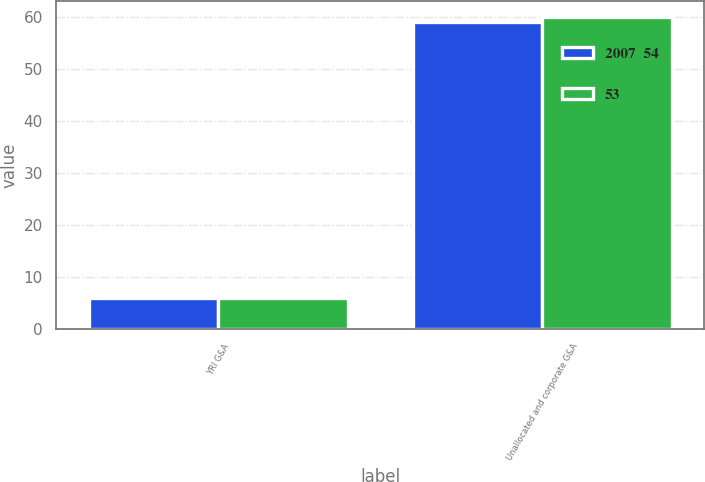Convert chart. <chart><loc_0><loc_0><loc_500><loc_500><stacked_bar_chart><ecel><fcel>YRI G&A<fcel>Unallocated and corporate G&A<nl><fcel>2007  54<fcel>6<fcel>59<nl><fcel>53<fcel>6<fcel>60<nl></chart> 